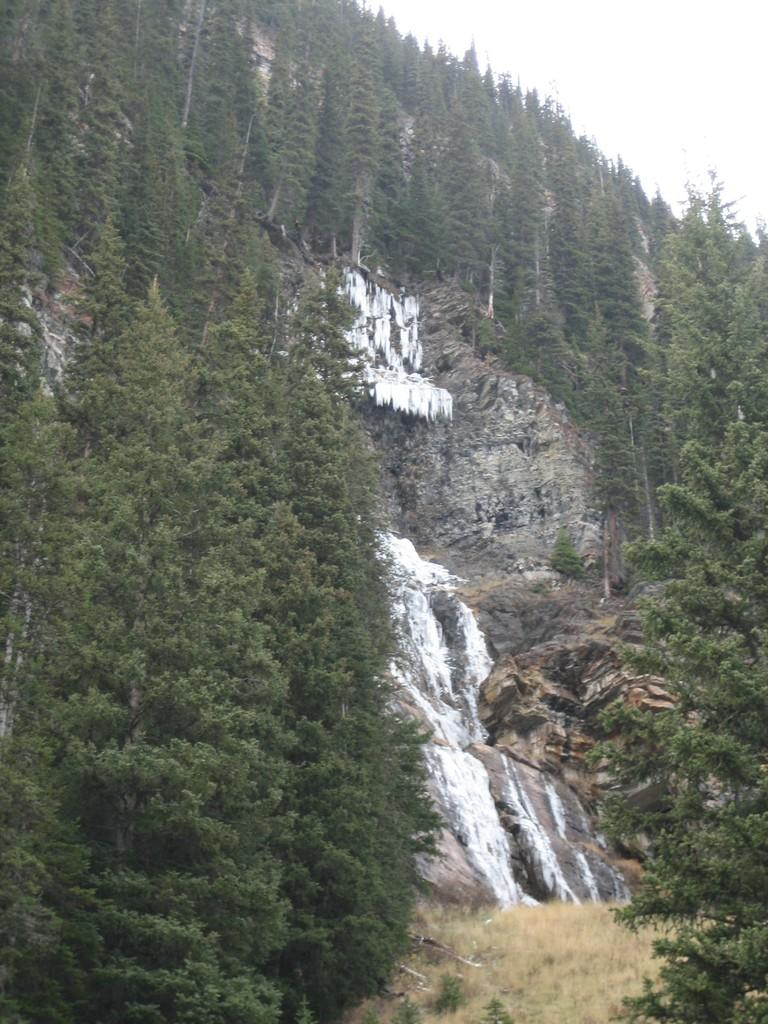What type of vegetation can be seen in the image? There are trees, plants, and grass visible in the image. What natural feature is present in the image? There is a mountain in the image. What can be seen in the background of the image? The sky is visible in the background of the image. Is there any water visible in the image? Yes, there is water visible in the image. How many cups are placed on the trees in the image? There are no cups present on the trees in the image. 